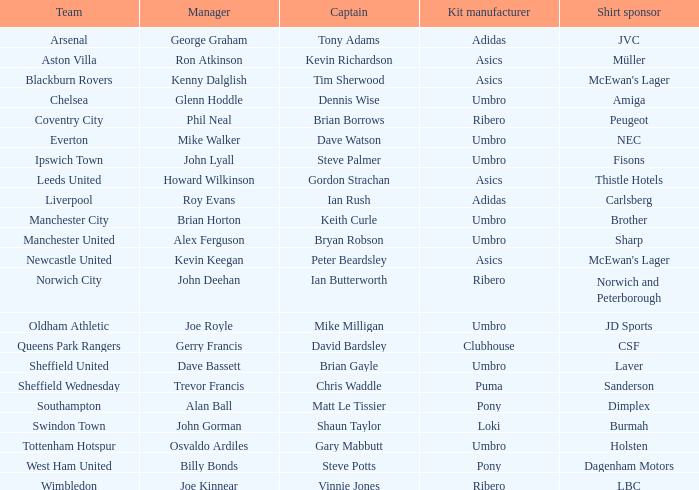Who is the manager of sheffield wednesday team? Trevor Francis. 